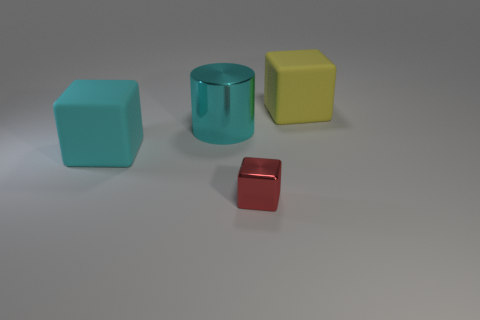What concepts could a teacher explain using these objects? A teacher could use these objects to explain several concepts. For example, they can teach about colors and shapes, spatial relationships such as 'in front of' or 'behind', size comparisons, and introductory math concepts like counting or sorting by attributes. 